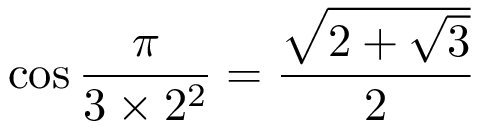Convert formula to latex. <formula><loc_0><loc_0><loc_500><loc_500>\cos { \frac { \pi } { 3 \times 2 ^ { 2 } } } = { \frac { \sqrt { 2 + { \sqrt { 3 } } } } { 2 } }</formula> 